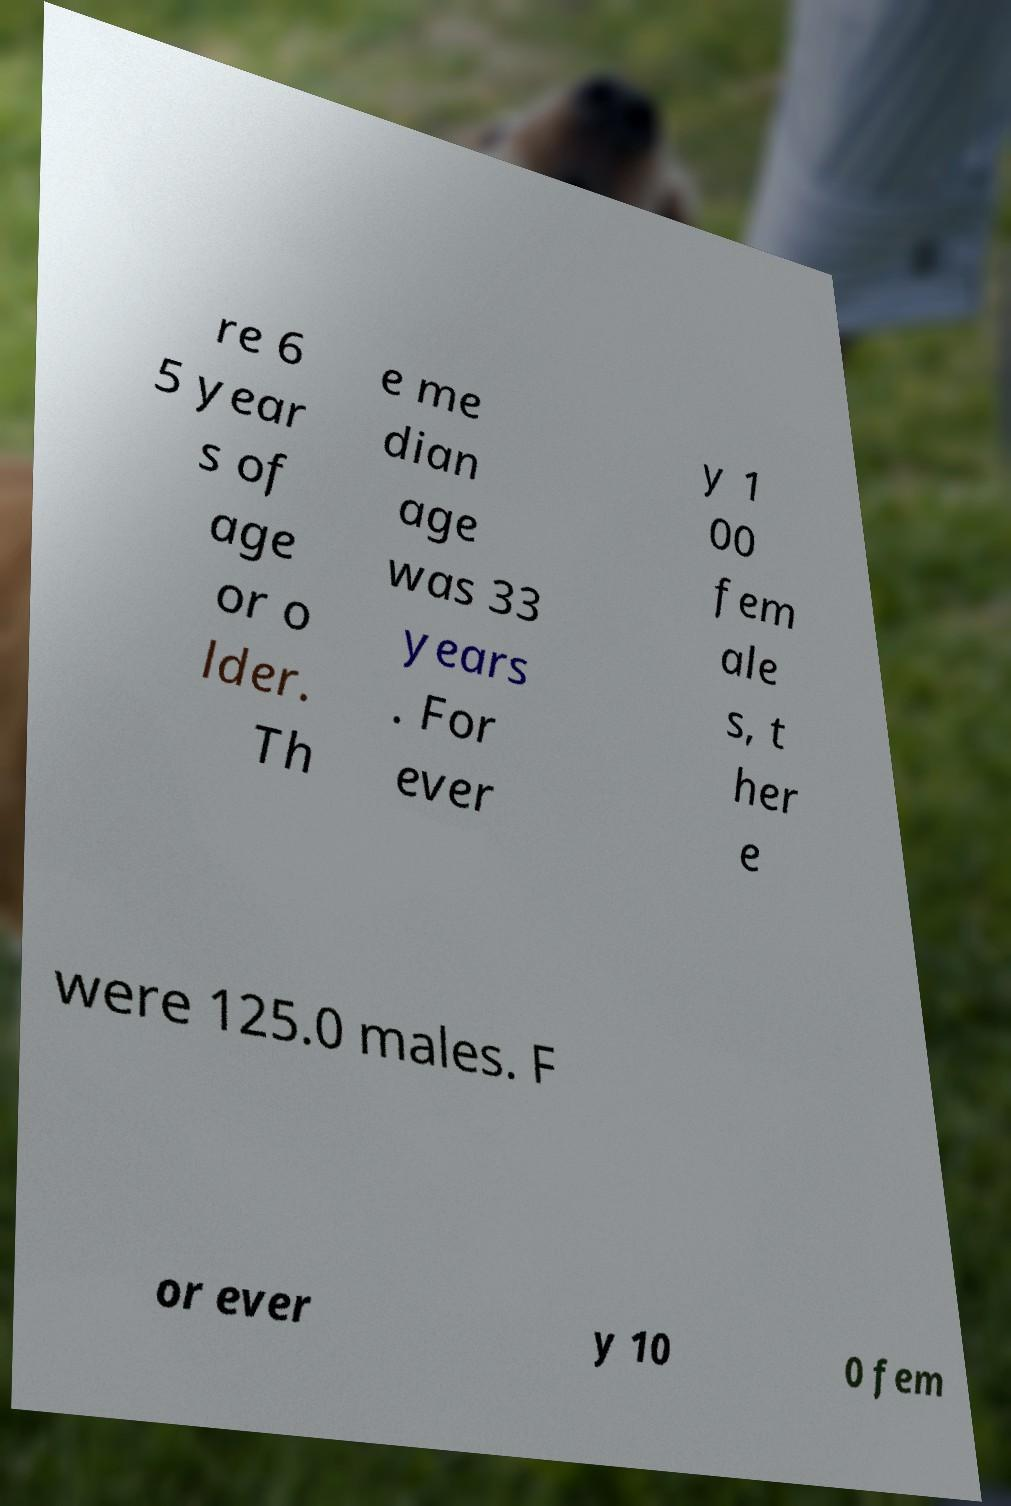I need the written content from this picture converted into text. Can you do that? re 6 5 year s of age or o lder. Th e me dian age was 33 years . For ever y 1 00 fem ale s, t her e were 125.0 males. F or ever y 10 0 fem 